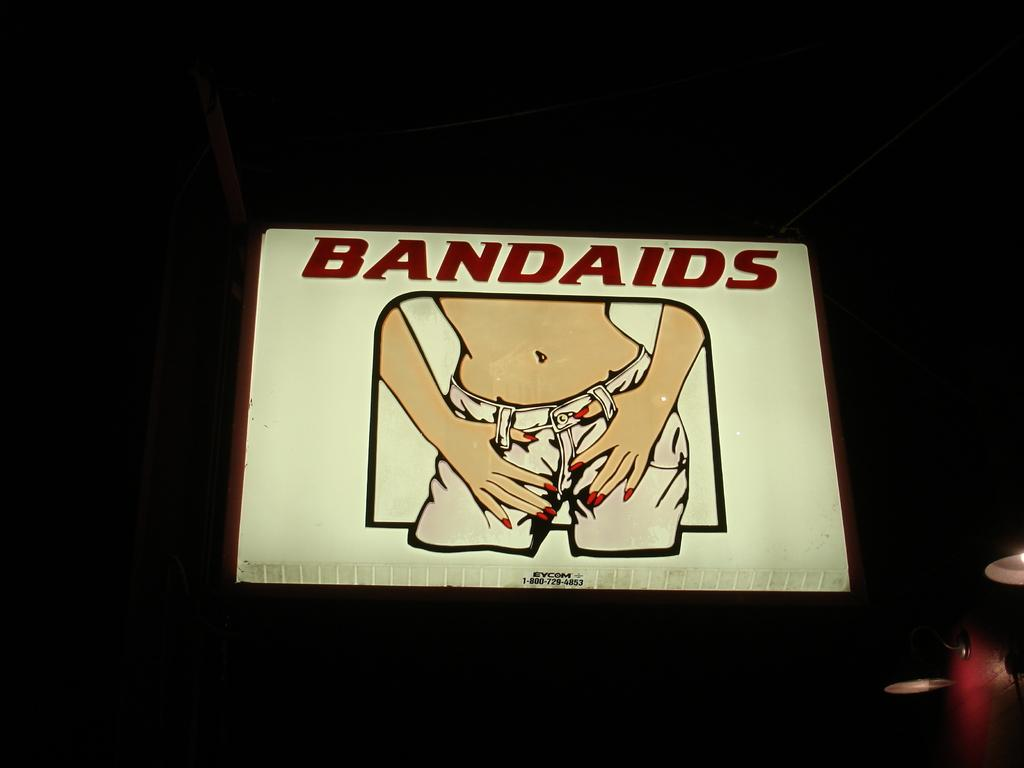What is the main subject in the center of the image? There is a board in the center of the image. What can be seen on the board? There is text written on the board. What else is visible in the image besides the board? There are objects visible in the image. What is the color of the background in the image? The background of the image is dark. What type of scent can be detected from the objects in the image? There is no information about the scent of the objects in the image, as the facts provided do not mention any scents. What question is being asked on the board in the image? The facts provided do not mention any specific question being asked on the board; only that there is text written on it. How many horses are visible in the image? There are no horses present in the image. 